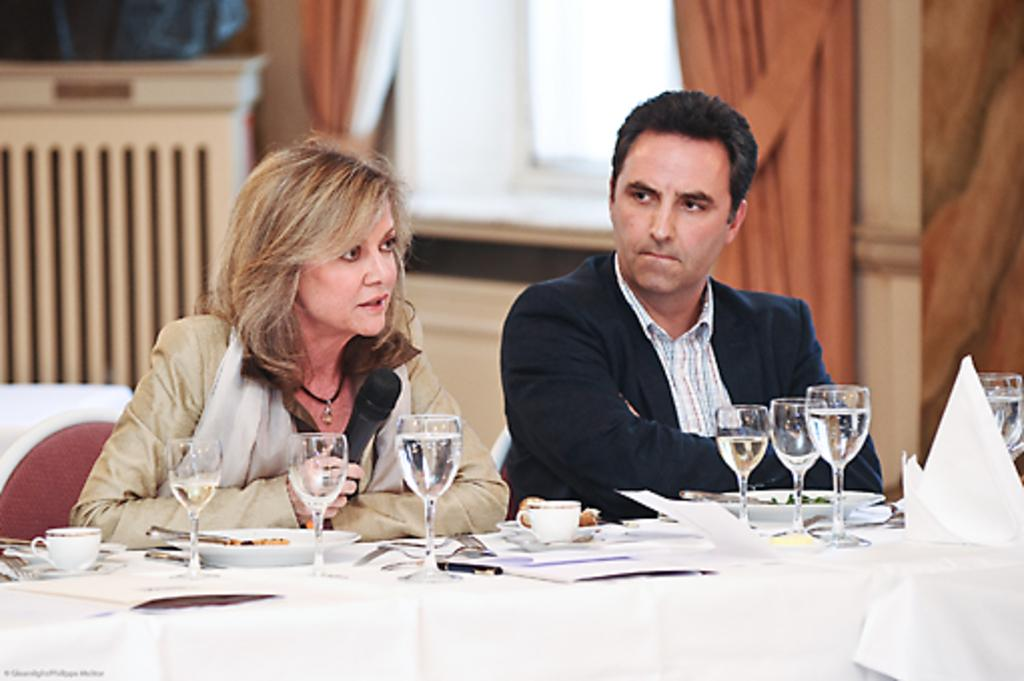How many people are in the image? There are two people in the image, a man and a woman. What are the man and woman doing in the image? Both the man and woman are sitting on chairs. What is present in the image besides the man and woman? There is a table in the image with different items on it, including glass, plates, and food items. What type of note is the man playing on the bell in the image? There is no bell or note-playing in the image; it only features a man and a woman sitting on chairs with a table nearby. 